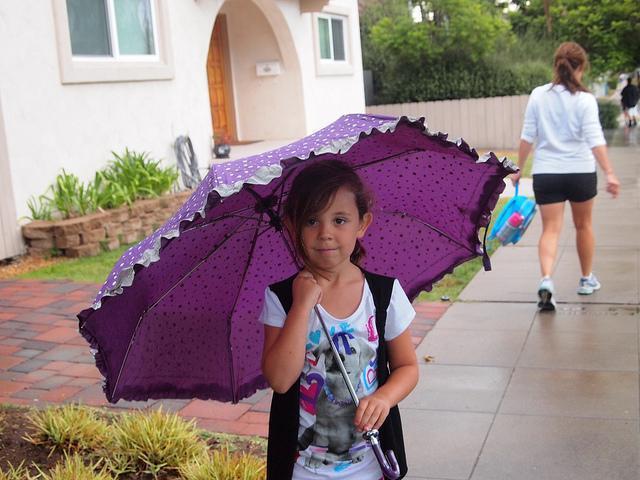Is the given caption "The umbrella is in front of the potted plant." fitting for the image?
Answer yes or no. Yes. 